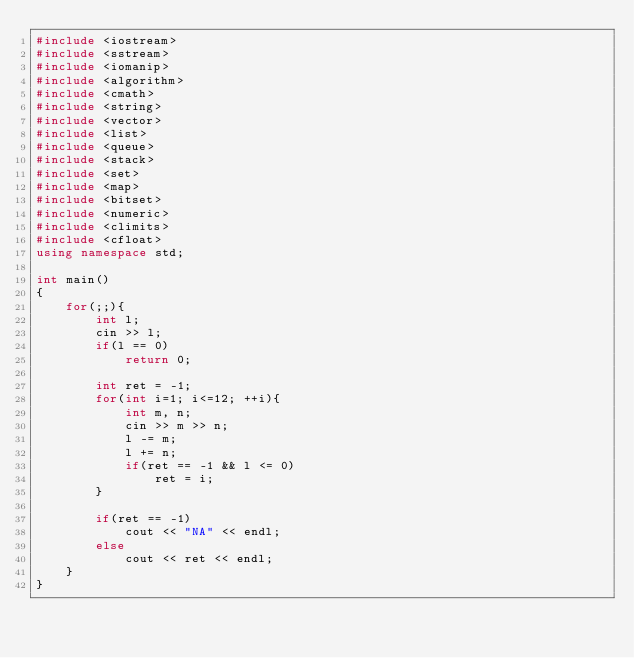Convert code to text. <code><loc_0><loc_0><loc_500><loc_500><_C++_>#include <iostream>
#include <sstream>
#include <iomanip>
#include <algorithm>
#include <cmath>
#include <string>
#include <vector>
#include <list>
#include <queue>
#include <stack>
#include <set>
#include <map>
#include <bitset>
#include <numeric>
#include <climits>
#include <cfloat>
using namespace std;

int main()
{
    for(;;){
        int l;
        cin >> l;
        if(l == 0)
            return 0;

        int ret = -1;
        for(int i=1; i<=12; ++i){
            int m, n;
            cin >> m >> n;
            l -= m;
            l += n;
            if(ret == -1 && l <= 0)
                ret = i;
        }

        if(ret == -1)
            cout << "NA" << endl;
        else
            cout << ret << endl;
    }
}</code> 